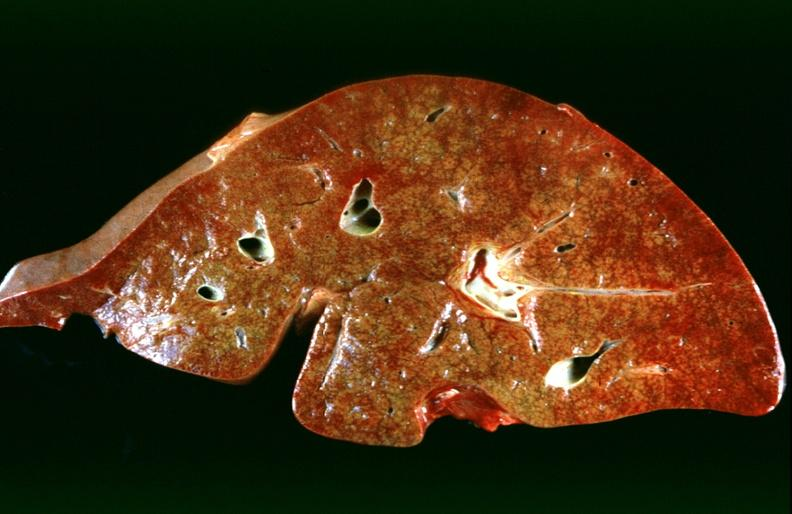what is present?
Answer the question using a single word or phrase. Liver 